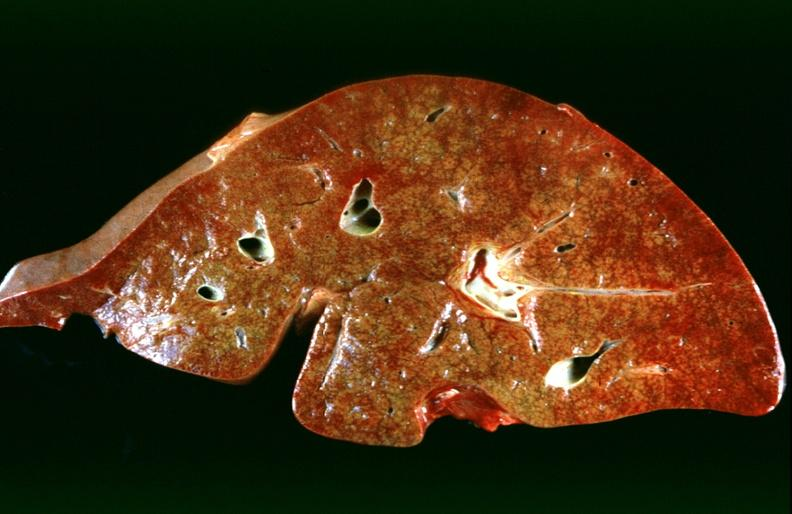what is present?
Answer the question using a single word or phrase. Liver 